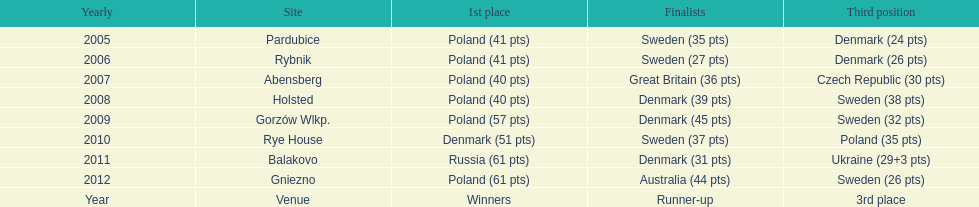After 2008 how many points total were scored by winners? 230. 